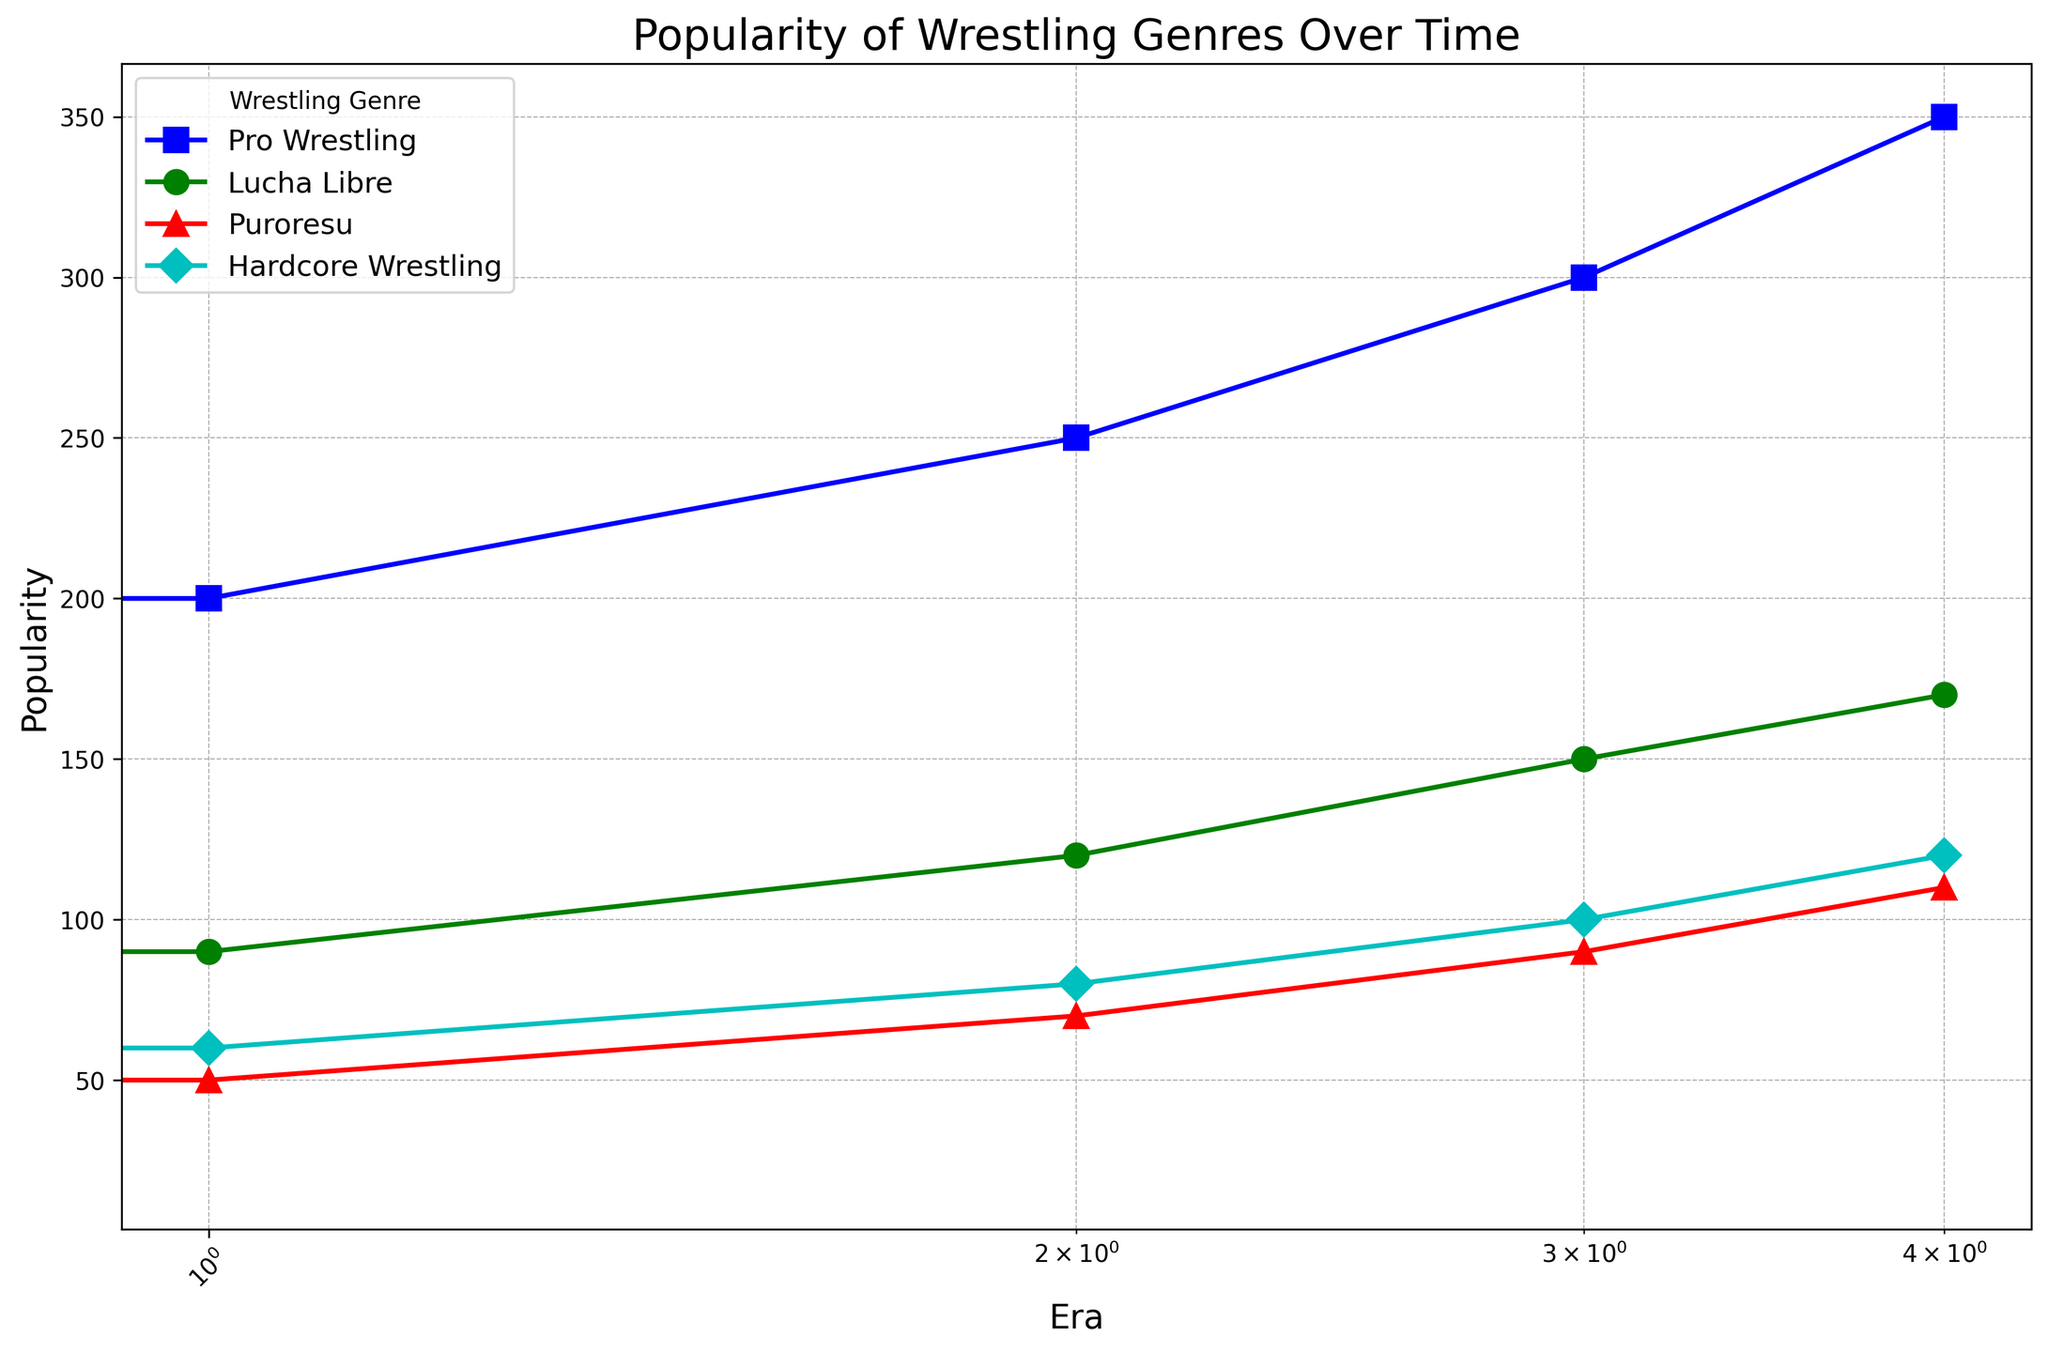Which genre had the highest popularity in the 2010s? From the chart, look at the 2010s era on the x-axis and identify the genre with the highest popularity on the y-axis. Pro Wrestling has the highest value.
Answer: Pro Wrestling How does the popularity of Hardcore Wrestling in the 2000s compare to that in the 1990s? On the chart, locate the values for Hardcore Wrestling in the 1990s and 2000s. In the 1990s, the popularity is 60 and in the 2000s it is 80. Comparing these values shows it increased.
Answer: It increased By how much did the popularity of Lucha Libre increase from the 1980s to the 2020s? Look at Lucha Libre's popularity values in the 1980s and 2020s on the chart. Subtract the value for the 1980s (70) from the value for the 2020s (170) to find the increase: 170 - 70 = 100.
Answer: 100 Which genre had the lowest popularity in the 1980s and what was its value? Identify the genre with the smallest y-axis value in the 1980s. Puroresu, with a value of 30, is the lowest.
Answer: Puroresu, 30 What is the average popularity of Pro Wrestling across all eras? Sum the popularity values of Pro Wrestling for all eras (150+200+250+300+350) which is 1250, and divide by the number of eras (5). 1250 / 5 = 250.
Answer: 250 Among all genres, which one showed the largest absolute increase in popularity from the 1980s to the 2020s? Compare the increase in popularity for each genre from the 1980s to the 2020s. Pro Wrestling increased by 200 (350-150), Lucha Libre by 100 (170-70), Puroresu by 80 (110-30), Hardcore Wrestling by 100 (120-20). Pro Wrestling had the largest increase.
Answer: Pro Wrestling Which genre had the most consistent increase in popularity across the eras? To find the most consistent increase, check the trends for each genre. Pro Wrestling shows a steadily increasing trend across all eras.
Answer: Pro Wrestling 